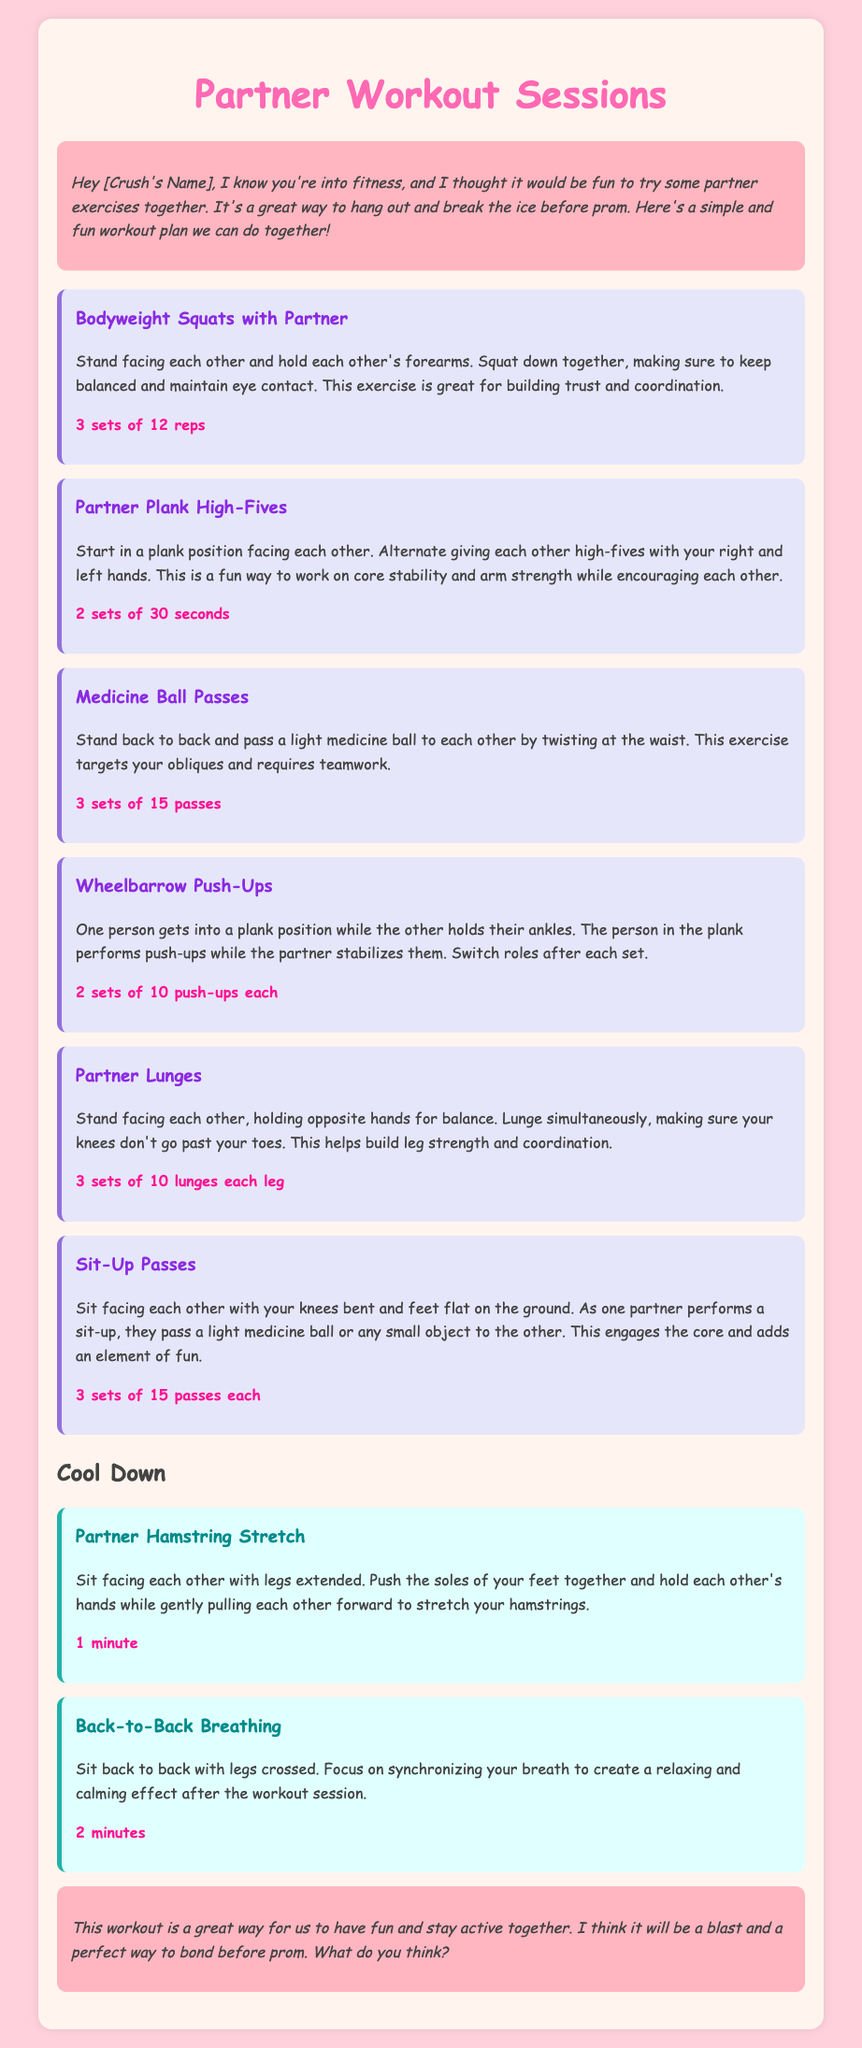What is the title of the workout plan? The title is the main heading of the document that describes the content.
Answer: Partner Workout Sessions How many exercises are listed in the workout plan? The number of exercises can be counted from the exercises section of the document.
Answer: 6 What is the first exercise mentioned in the plan? The first exercise is typically the one listed at the start of the exercises section.
Answer: Bodyweight Squats with Partner What do partners do during the Plank High-Fives? This requires knowledge of the specific activity described in the second exercise.
Answer: High-fives How many sets of lunges should each partner do? This information is found in the description of the lunges exercise which specifies the number of sets.
Answer: 3 sets of 10 lunges each leg What is the duration of the Partner Hamstring Stretch? This is the time given in the cool-down section for the hamstring stretch.
Answer: 1 minute What is the goal of doing partner exercises according to the introduction? The introduction mentions a purpose for doing partner exercises which reflects on time spent together.
Answer: Hang out and break the ice What type of workout document is this? This question pertains to the classification of the document based on its content and structure.
Answer: Workout plan 